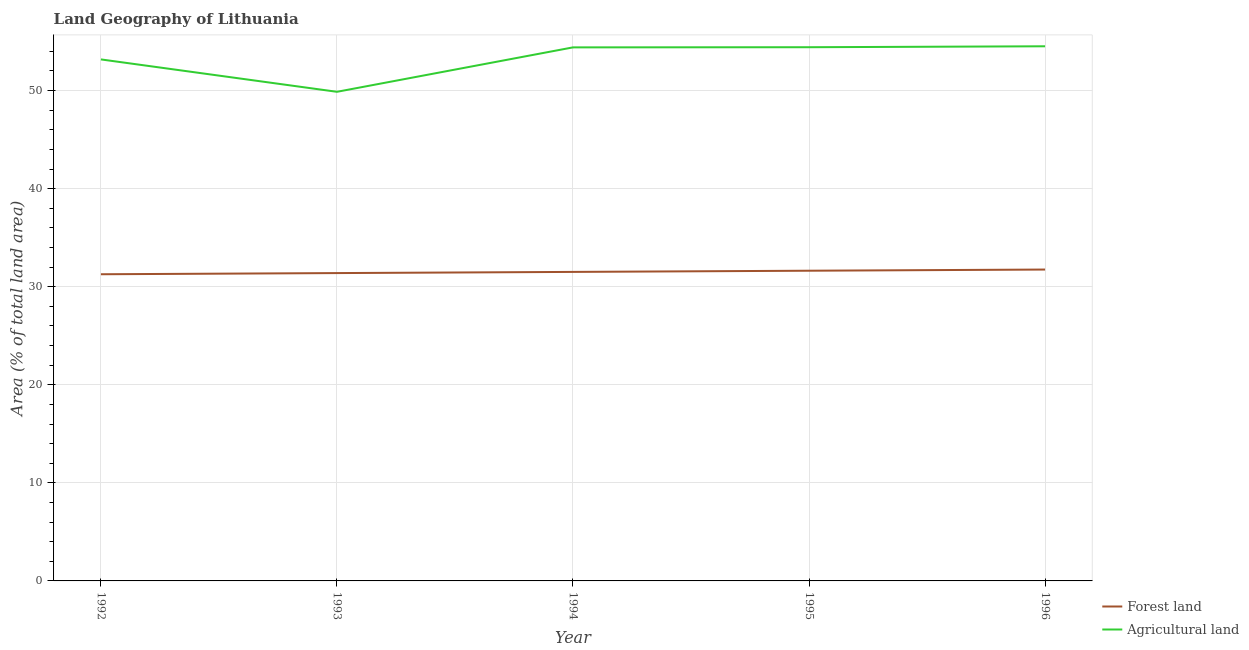How many different coloured lines are there?
Make the answer very short. 2. Is the number of lines equal to the number of legend labels?
Provide a succinct answer. Yes. What is the percentage of land area under forests in 1992?
Offer a terse response. 31.27. Across all years, what is the maximum percentage of land area under forests?
Your answer should be compact. 31.75. Across all years, what is the minimum percentage of land area under agriculture?
Offer a terse response. 49.87. In which year was the percentage of land area under forests minimum?
Your response must be concise. 1992. What is the total percentage of land area under agriculture in the graph?
Your response must be concise. 266.38. What is the difference between the percentage of land area under forests in 1995 and that in 1996?
Give a very brief answer. -0.12. What is the difference between the percentage of land area under agriculture in 1994 and the percentage of land area under forests in 1995?
Your answer should be compact. 22.77. What is the average percentage of land area under forests per year?
Your response must be concise. 31.51. In the year 1993, what is the difference between the percentage of land area under forests and percentage of land area under agriculture?
Give a very brief answer. -18.48. In how many years, is the percentage of land area under forests greater than 46 %?
Offer a terse response. 0. What is the ratio of the percentage of land area under forests in 1992 to that in 1995?
Make the answer very short. 0.99. Is the percentage of land area under agriculture in 1993 less than that in 1995?
Your answer should be compact. Yes. Is the difference between the percentage of land area under forests in 1995 and 1996 greater than the difference between the percentage of land area under agriculture in 1995 and 1996?
Ensure brevity in your answer.  No. What is the difference between the highest and the second highest percentage of land area under forests?
Your response must be concise. 0.12. What is the difference between the highest and the lowest percentage of land area under agriculture?
Make the answer very short. 4.64. In how many years, is the percentage of land area under forests greater than the average percentage of land area under forests taken over all years?
Your response must be concise. 2. Does the percentage of land area under agriculture monotonically increase over the years?
Your answer should be very brief. No. Is the percentage of land area under agriculture strictly less than the percentage of land area under forests over the years?
Make the answer very short. No. How many lines are there?
Offer a terse response. 2. Are the values on the major ticks of Y-axis written in scientific E-notation?
Offer a very short reply. No. How are the legend labels stacked?
Provide a succinct answer. Vertical. What is the title of the graph?
Your answer should be very brief. Land Geography of Lithuania. What is the label or title of the X-axis?
Keep it short and to the point. Year. What is the label or title of the Y-axis?
Keep it short and to the point. Area (% of total land area). What is the Area (% of total land area) in Forest land in 1992?
Make the answer very short. 31.27. What is the Area (% of total land area) of Agricultural land in 1992?
Your answer should be very brief. 53.17. What is the Area (% of total land area) in Forest land in 1993?
Ensure brevity in your answer.  31.39. What is the Area (% of total land area) in Agricultural land in 1993?
Provide a succinct answer. 49.87. What is the Area (% of total land area) in Forest land in 1994?
Ensure brevity in your answer.  31.51. What is the Area (% of total land area) in Agricultural land in 1994?
Your answer should be very brief. 54.4. What is the Area (% of total land area) of Forest land in 1995?
Give a very brief answer. 31.63. What is the Area (% of total land area) in Agricultural land in 1995?
Your answer should be very brief. 54.42. What is the Area (% of total land area) of Forest land in 1996?
Offer a very short reply. 31.75. What is the Area (% of total land area) in Agricultural land in 1996?
Your response must be concise. 54.51. Across all years, what is the maximum Area (% of total land area) in Forest land?
Ensure brevity in your answer.  31.75. Across all years, what is the maximum Area (% of total land area) in Agricultural land?
Make the answer very short. 54.51. Across all years, what is the minimum Area (% of total land area) of Forest land?
Provide a succinct answer. 31.27. Across all years, what is the minimum Area (% of total land area) in Agricultural land?
Offer a very short reply. 49.87. What is the total Area (% of total land area) in Forest land in the graph?
Offer a very short reply. 157.55. What is the total Area (% of total land area) in Agricultural land in the graph?
Offer a terse response. 266.38. What is the difference between the Area (% of total land area) of Forest land in 1992 and that in 1993?
Offer a terse response. -0.12. What is the difference between the Area (% of total land area) in Agricultural land in 1992 and that in 1993?
Keep it short and to the point. 3.3. What is the difference between the Area (% of total land area) of Forest land in 1992 and that in 1994?
Your response must be concise. -0.24. What is the difference between the Area (% of total land area) of Agricultural land in 1992 and that in 1994?
Provide a succinct answer. -1.23. What is the difference between the Area (% of total land area) of Forest land in 1992 and that in 1995?
Provide a short and direct response. -0.36. What is the difference between the Area (% of total land area) of Agricultural land in 1992 and that in 1995?
Keep it short and to the point. -1.24. What is the difference between the Area (% of total land area) of Forest land in 1992 and that in 1996?
Offer a very short reply. -0.48. What is the difference between the Area (% of total land area) in Agricultural land in 1992 and that in 1996?
Your answer should be very brief. -1.34. What is the difference between the Area (% of total land area) of Forest land in 1993 and that in 1994?
Offer a terse response. -0.12. What is the difference between the Area (% of total land area) of Agricultural land in 1993 and that in 1994?
Your answer should be very brief. -4.53. What is the difference between the Area (% of total land area) in Forest land in 1993 and that in 1995?
Offer a terse response. -0.24. What is the difference between the Area (% of total land area) of Agricultural land in 1993 and that in 1995?
Give a very brief answer. -4.55. What is the difference between the Area (% of total land area) of Forest land in 1993 and that in 1996?
Your response must be concise. -0.36. What is the difference between the Area (% of total land area) in Agricultural land in 1993 and that in 1996?
Ensure brevity in your answer.  -4.64. What is the difference between the Area (% of total land area) in Forest land in 1994 and that in 1995?
Offer a terse response. -0.12. What is the difference between the Area (% of total land area) of Agricultural land in 1994 and that in 1995?
Make the answer very short. -0.02. What is the difference between the Area (% of total land area) in Forest land in 1994 and that in 1996?
Provide a succinct answer. -0.24. What is the difference between the Area (% of total land area) in Agricultural land in 1994 and that in 1996?
Offer a terse response. -0.11. What is the difference between the Area (% of total land area) of Forest land in 1995 and that in 1996?
Ensure brevity in your answer.  -0.12. What is the difference between the Area (% of total land area) in Agricultural land in 1995 and that in 1996?
Your response must be concise. -0.1. What is the difference between the Area (% of total land area) in Forest land in 1992 and the Area (% of total land area) in Agricultural land in 1993?
Offer a terse response. -18.6. What is the difference between the Area (% of total land area) of Forest land in 1992 and the Area (% of total land area) of Agricultural land in 1994?
Your answer should be very brief. -23.13. What is the difference between the Area (% of total land area) of Forest land in 1992 and the Area (% of total land area) of Agricultural land in 1995?
Offer a very short reply. -23.15. What is the difference between the Area (% of total land area) of Forest land in 1992 and the Area (% of total land area) of Agricultural land in 1996?
Ensure brevity in your answer.  -23.25. What is the difference between the Area (% of total land area) of Forest land in 1993 and the Area (% of total land area) of Agricultural land in 1994?
Keep it short and to the point. -23.01. What is the difference between the Area (% of total land area) in Forest land in 1993 and the Area (% of total land area) in Agricultural land in 1995?
Provide a succinct answer. -23.03. What is the difference between the Area (% of total land area) of Forest land in 1993 and the Area (% of total land area) of Agricultural land in 1996?
Provide a short and direct response. -23.13. What is the difference between the Area (% of total land area) in Forest land in 1994 and the Area (% of total land area) in Agricultural land in 1995?
Your answer should be very brief. -22.91. What is the difference between the Area (% of total land area) in Forest land in 1994 and the Area (% of total land area) in Agricultural land in 1996?
Your answer should be very brief. -23.01. What is the difference between the Area (% of total land area) in Forest land in 1995 and the Area (% of total land area) in Agricultural land in 1996?
Your response must be concise. -22.89. What is the average Area (% of total land area) in Forest land per year?
Make the answer very short. 31.51. What is the average Area (% of total land area) of Agricultural land per year?
Ensure brevity in your answer.  53.28. In the year 1992, what is the difference between the Area (% of total land area) of Forest land and Area (% of total land area) of Agricultural land?
Provide a succinct answer. -21.9. In the year 1993, what is the difference between the Area (% of total land area) in Forest land and Area (% of total land area) in Agricultural land?
Ensure brevity in your answer.  -18.48. In the year 1994, what is the difference between the Area (% of total land area) of Forest land and Area (% of total land area) of Agricultural land?
Offer a terse response. -22.89. In the year 1995, what is the difference between the Area (% of total land area) of Forest land and Area (% of total land area) of Agricultural land?
Offer a very short reply. -22.79. In the year 1996, what is the difference between the Area (% of total land area) in Forest land and Area (% of total land area) in Agricultural land?
Provide a succinct answer. -22.77. What is the ratio of the Area (% of total land area) in Agricultural land in 1992 to that in 1993?
Your answer should be very brief. 1.07. What is the ratio of the Area (% of total land area) of Forest land in 1992 to that in 1994?
Your answer should be compact. 0.99. What is the ratio of the Area (% of total land area) in Agricultural land in 1992 to that in 1994?
Keep it short and to the point. 0.98. What is the ratio of the Area (% of total land area) of Forest land in 1992 to that in 1995?
Offer a very short reply. 0.99. What is the ratio of the Area (% of total land area) of Agricultural land in 1992 to that in 1995?
Your answer should be very brief. 0.98. What is the ratio of the Area (% of total land area) in Forest land in 1992 to that in 1996?
Give a very brief answer. 0.98. What is the ratio of the Area (% of total land area) in Agricultural land in 1992 to that in 1996?
Your response must be concise. 0.98. What is the ratio of the Area (% of total land area) in Forest land in 1993 to that in 1994?
Provide a short and direct response. 1. What is the ratio of the Area (% of total land area) in Forest land in 1993 to that in 1995?
Provide a succinct answer. 0.99. What is the ratio of the Area (% of total land area) of Agricultural land in 1993 to that in 1995?
Offer a very short reply. 0.92. What is the ratio of the Area (% of total land area) of Forest land in 1993 to that in 1996?
Your answer should be very brief. 0.99. What is the ratio of the Area (% of total land area) of Agricultural land in 1993 to that in 1996?
Keep it short and to the point. 0.91. What is the ratio of the Area (% of total land area) of Agricultural land in 1994 to that in 1995?
Provide a short and direct response. 1. What is the ratio of the Area (% of total land area) in Agricultural land in 1995 to that in 1996?
Provide a succinct answer. 1. What is the difference between the highest and the second highest Area (% of total land area) of Forest land?
Offer a very short reply. 0.12. What is the difference between the highest and the second highest Area (% of total land area) of Agricultural land?
Offer a terse response. 0.1. What is the difference between the highest and the lowest Area (% of total land area) of Forest land?
Ensure brevity in your answer.  0.48. What is the difference between the highest and the lowest Area (% of total land area) in Agricultural land?
Your answer should be compact. 4.64. 